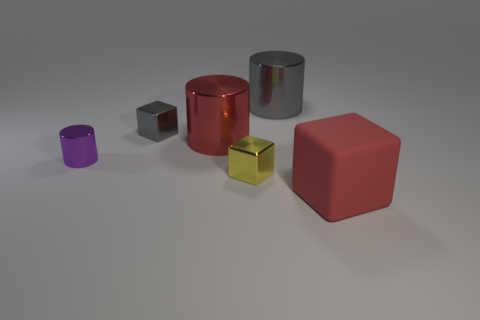Add 2 gray cylinders. How many objects exist? 8 Subtract all large red rubber blocks. How many blocks are left? 2 Subtract all yellow blocks. How many blocks are left? 2 Add 6 red cylinders. How many red cylinders exist? 7 Subtract 1 red cylinders. How many objects are left? 5 Subtract 3 cylinders. How many cylinders are left? 0 Subtract all cyan blocks. Subtract all cyan cylinders. How many blocks are left? 3 Subtract all green cylinders. How many green cubes are left? 0 Subtract all big yellow cylinders. Subtract all small yellow blocks. How many objects are left? 5 Add 1 metal cylinders. How many metal cylinders are left? 4 